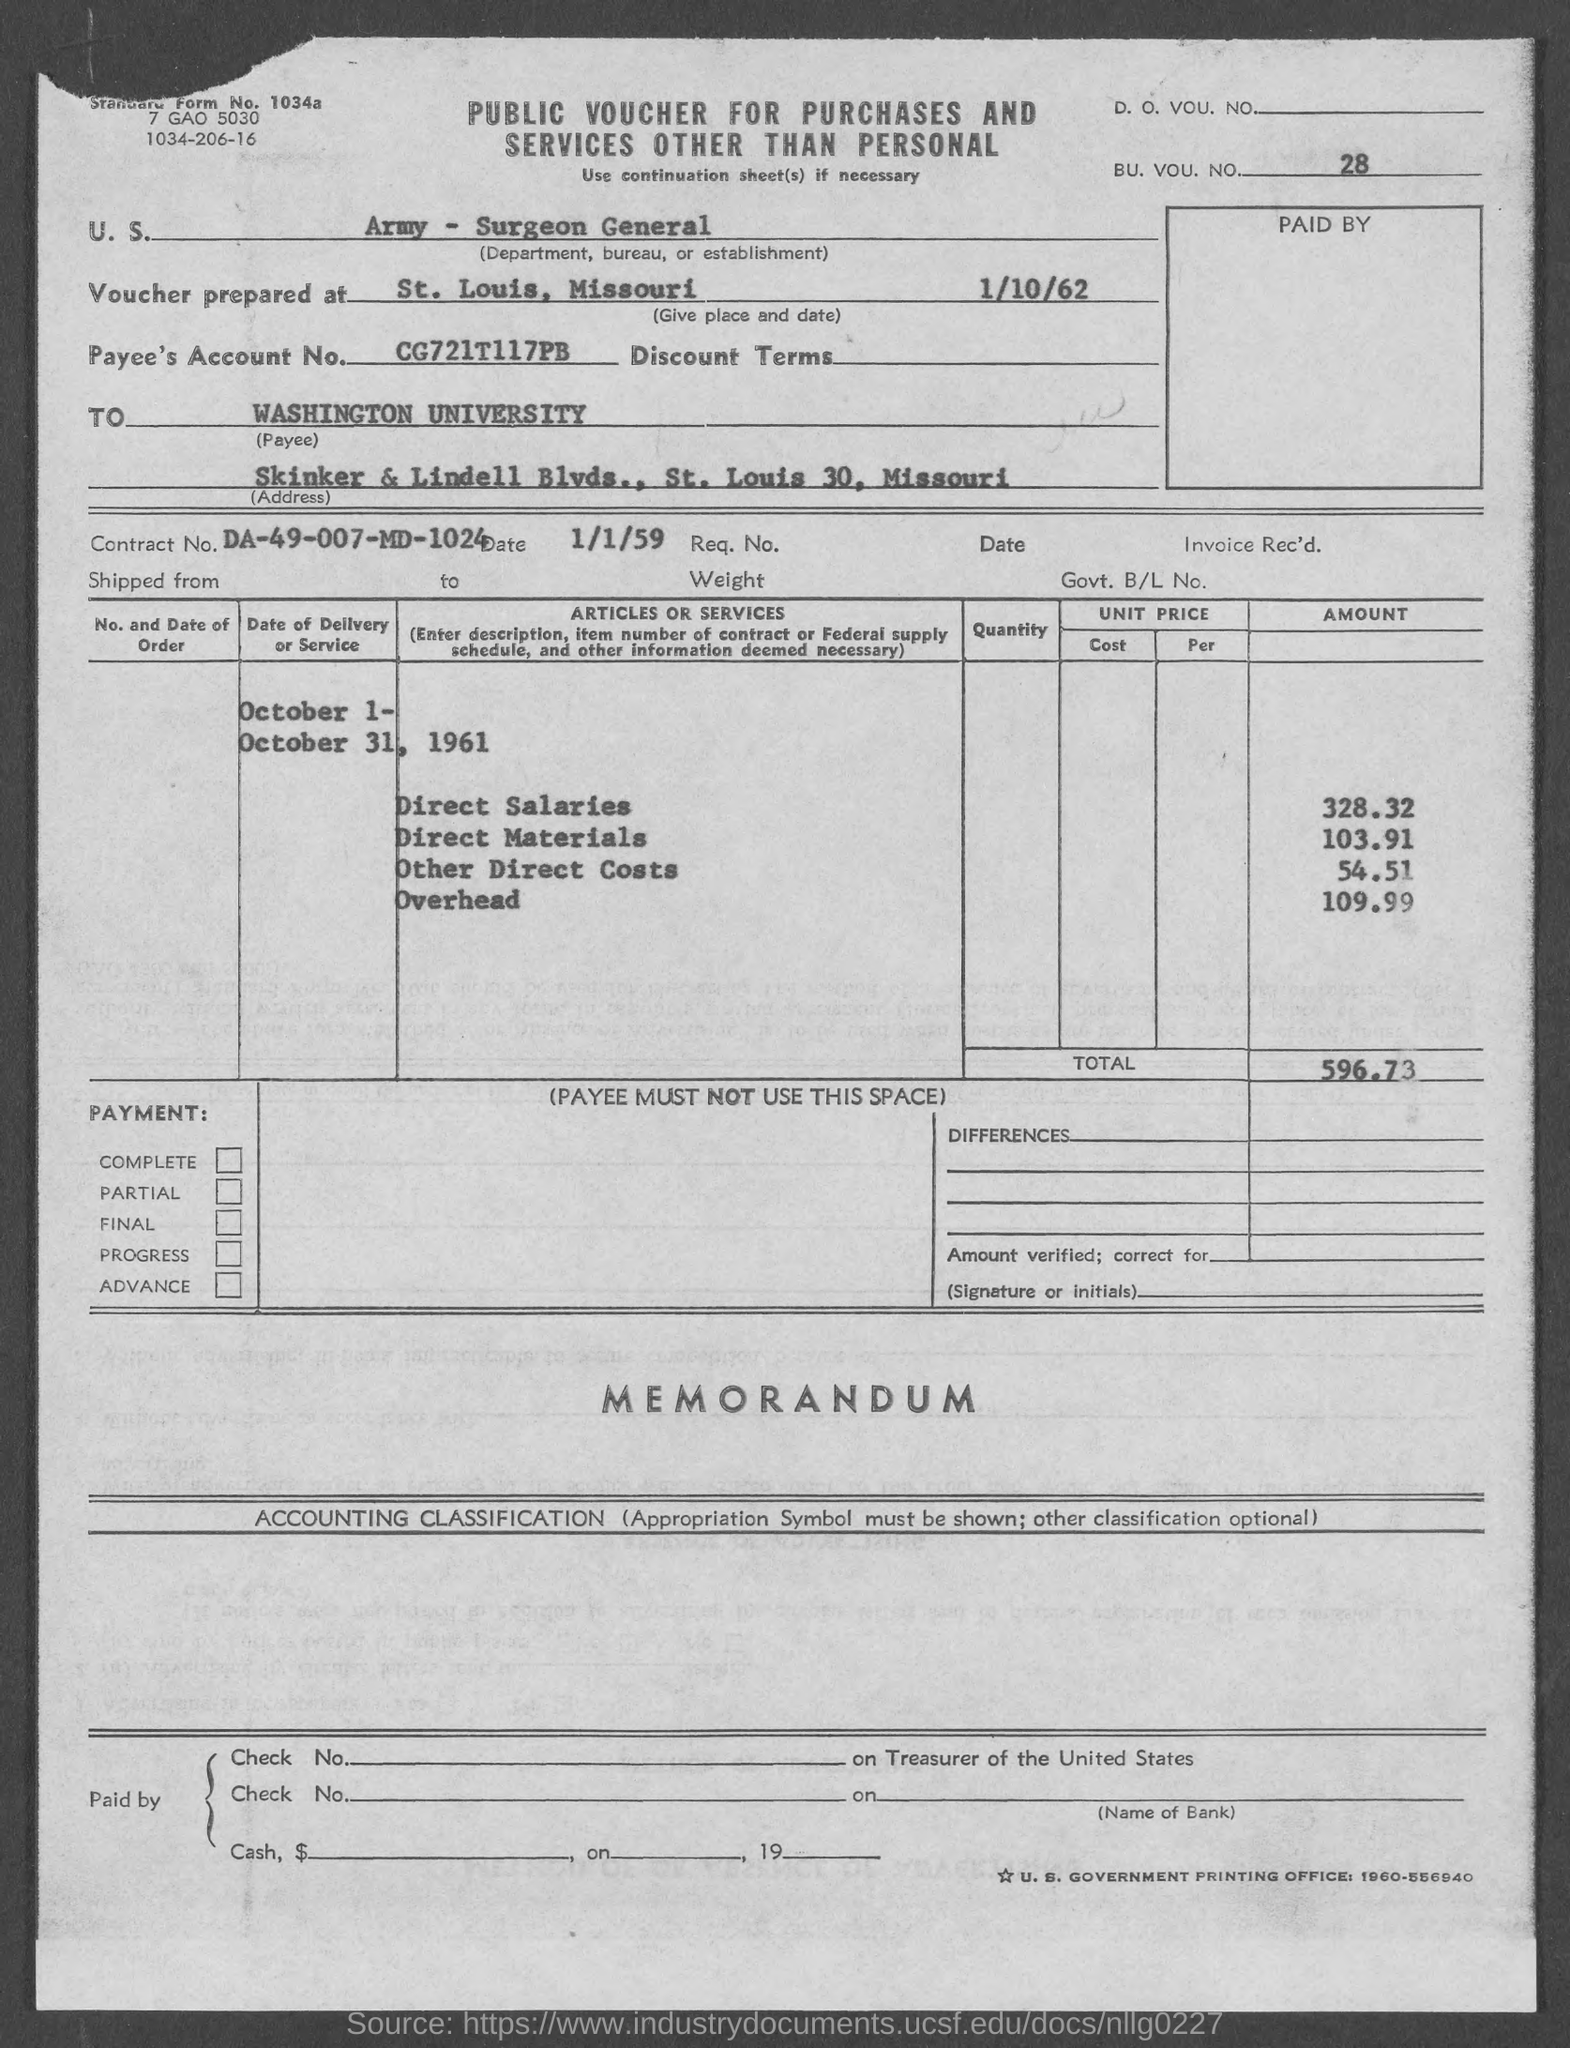Mention a couple of crucial points in this snapshot. The amount for other direct costs, as mentioned in the given form, is 54.51... The direct salaries mentioned in the given form are 328.32... The amount for overhead mentioned in the given form is 109.99. The voucher is prepared in St. Louis, Missouri. The amount of direct materials mentioned in the given page is 103.91. 